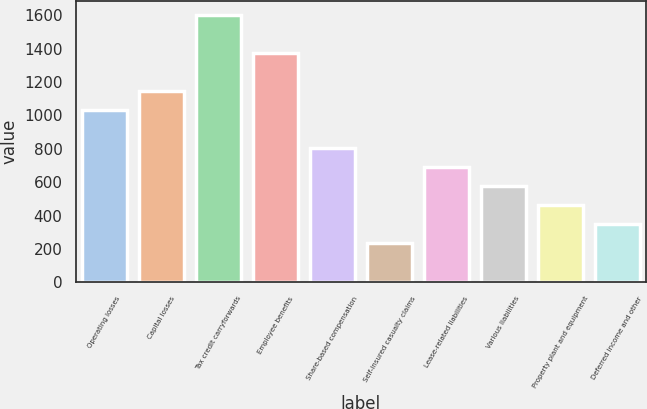Convert chart. <chart><loc_0><loc_0><loc_500><loc_500><bar_chart><fcel>Operating losses<fcel>Capital losses<fcel>Tax credit carryforwards<fcel>Employee benefits<fcel>Share-based compensation<fcel>Self-insured casualty claims<fcel>Lease-related liabilities<fcel>Various liabilities<fcel>Property plant and equipment<fcel>Deferred income and other<nl><fcel>1032.9<fcel>1147<fcel>1603.4<fcel>1375.2<fcel>804.7<fcel>234.2<fcel>690.6<fcel>576.5<fcel>462.4<fcel>348.3<nl></chart> 